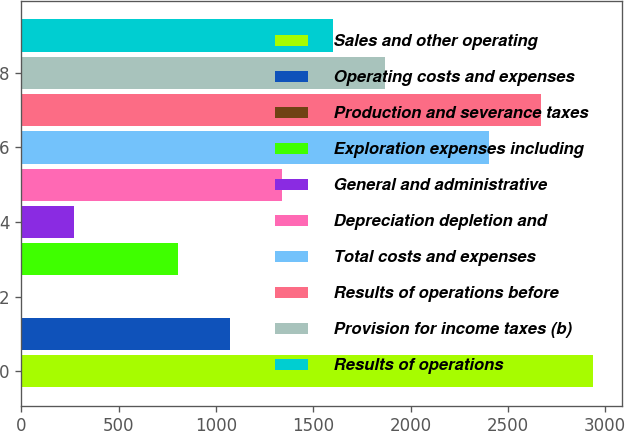<chart> <loc_0><loc_0><loc_500><loc_500><bar_chart><fcel>Sales and other operating<fcel>Operating costs and expenses<fcel>Production and severance taxes<fcel>Exploration expenses including<fcel>General and administrative<fcel>Depreciation depletion and<fcel>Total costs and expenses<fcel>Results of operations before<fcel>Provision for income taxes (b)<fcel>Results of operations<nl><fcel>2937.8<fcel>1070.2<fcel>3<fcel>803.4<fcel>269.8<fcel>1337<fcel>2404.2<fcel>2671<fcel>1870.6<fcel>1603.8<nl></chart> 